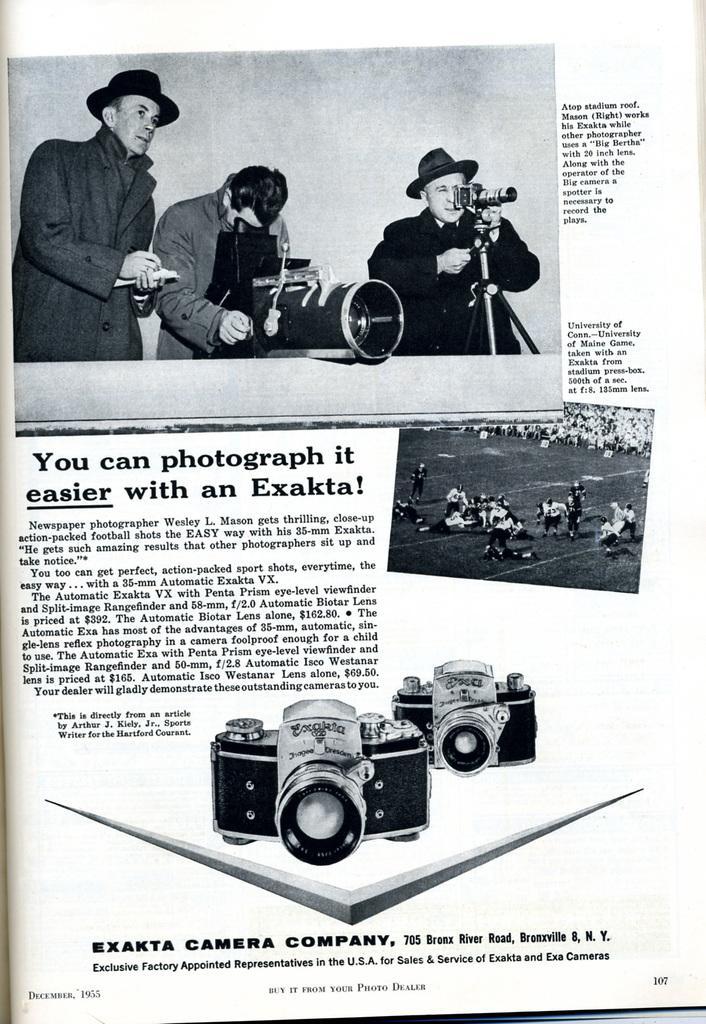In one or two sentences, can you explain what this image depicts? In this image I can see there is a paper and this at the top man is standing, he wore a coat, hat. Beside him another man is looking into the camera, at the bottom there are cameras with matter. 